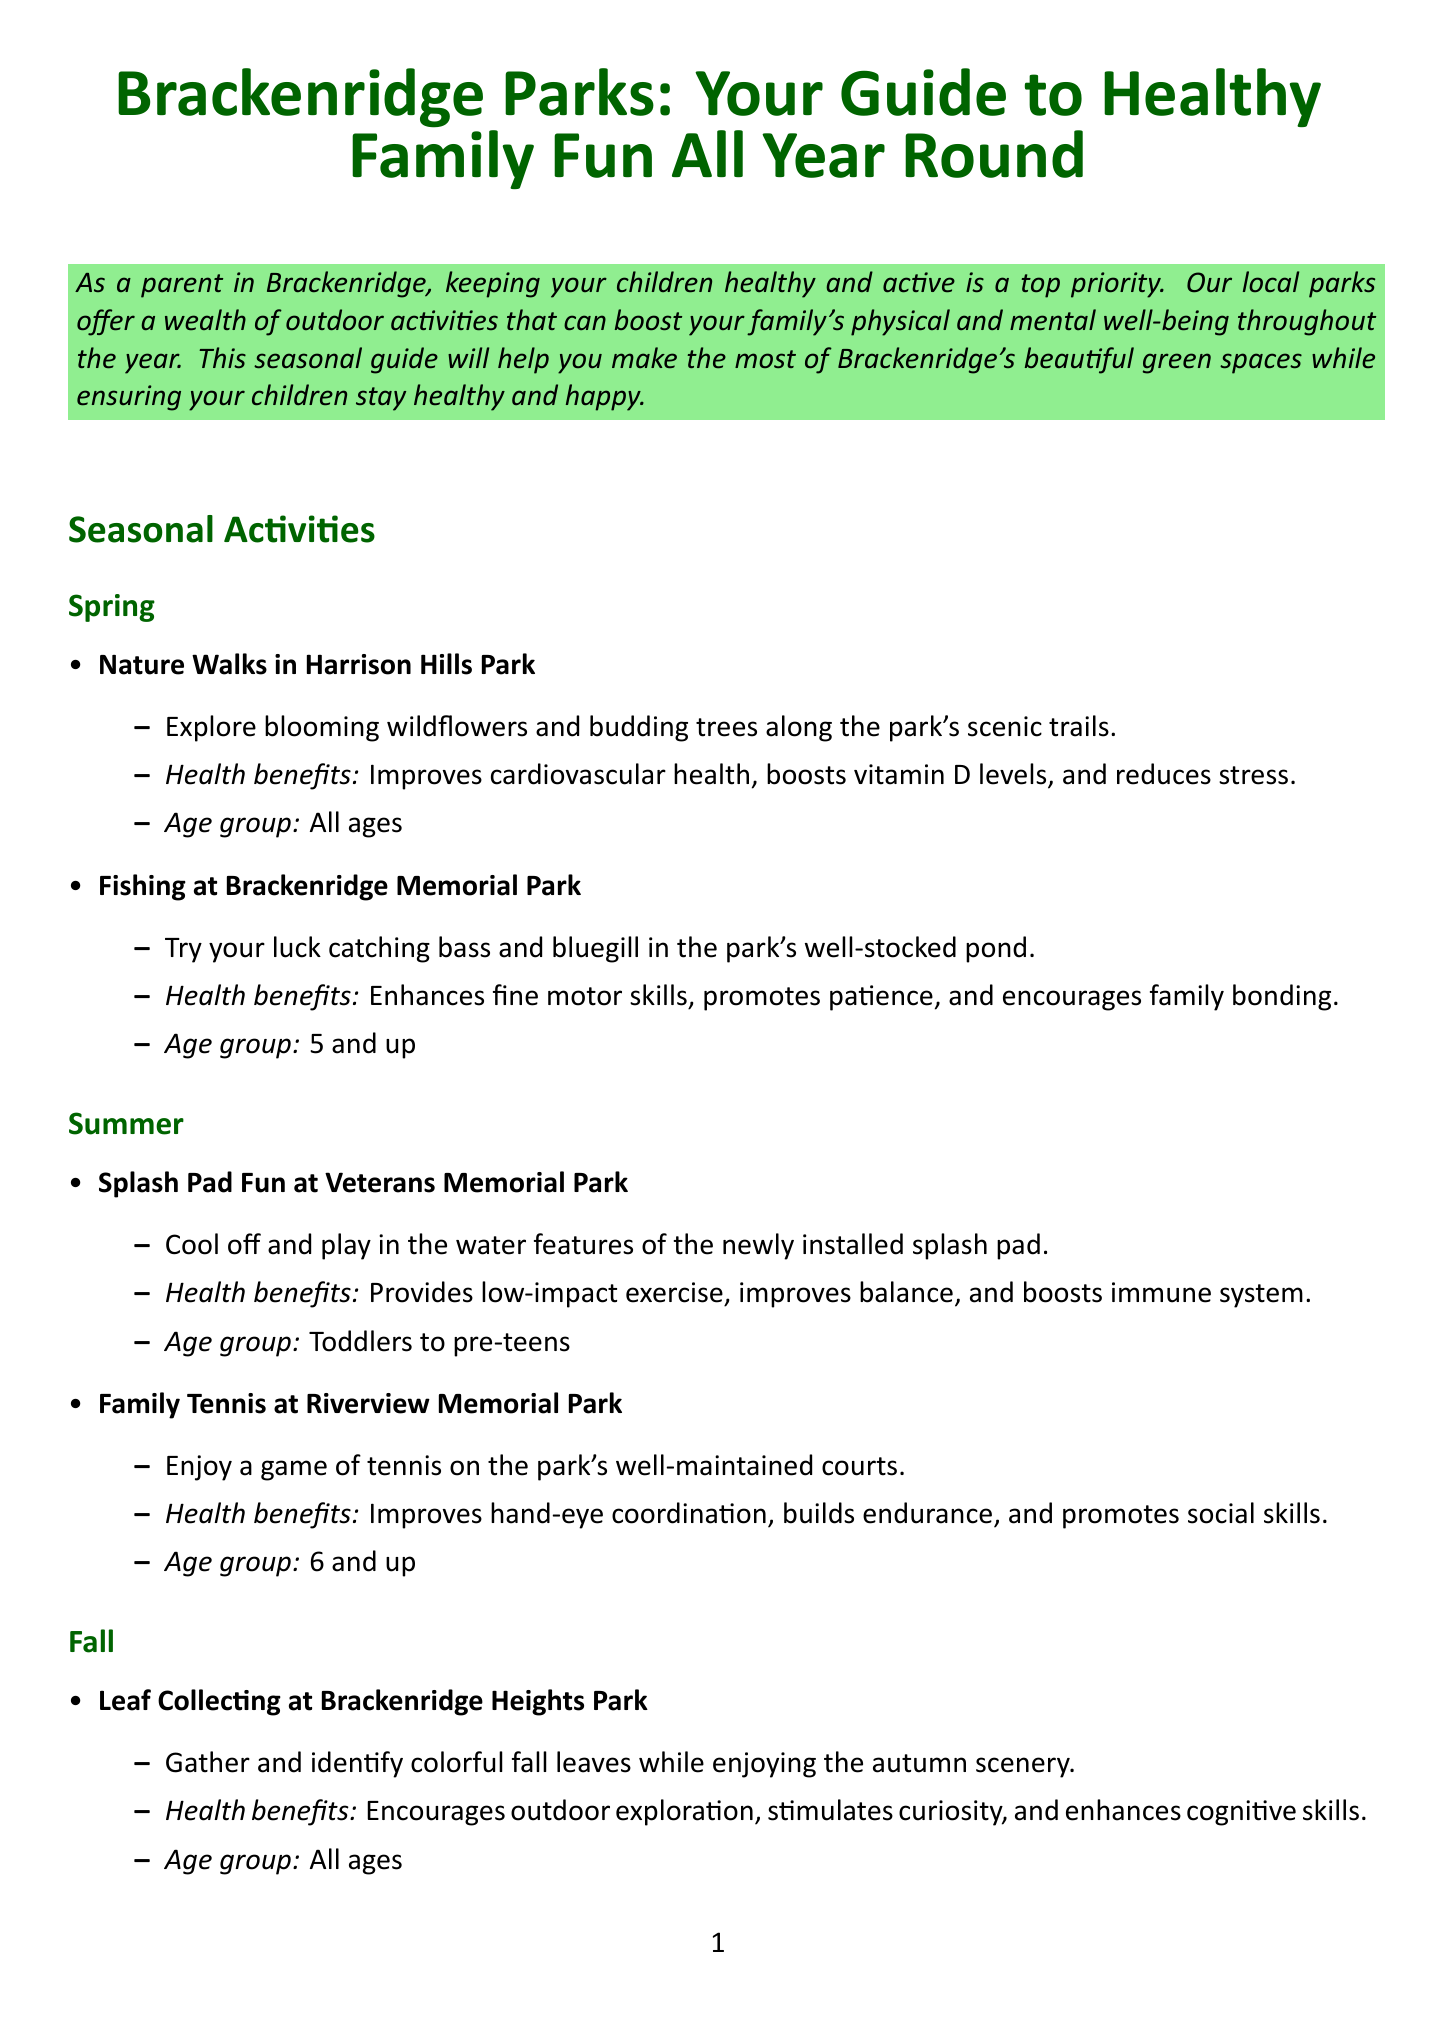What is the title of the newsletter? The title is presented prominently at the beginning of the document and serves as the main heading.
Answer: Brackenridge Parks: Your Guide to Healthy Family Fun All Year Round What is one health benefit of fishing at Brackenridge Memorial Park? Fishing is highlighted within the seasonal activities, emphasizing its health benefits for children.
Answer: Enhances fine motor skills What age group is suggested for Family Tennis at Riverview Memorial Park? The recommended age group is explicitly mentioned under the activity section of summer.
Answer: 6 and up Which park offers a splash pad for cooling off? The document specifies the location of the splash pad under summer activities.
Answer: Veterans Memorial Park What are two health tips mentioned in the newsletter? The health tips provide practical advice for outdoor activities, detailed in a list format.
Answer: Always apply sunscreen, Stay hydrated What seasonal activity encourages outdoor exploration during fall? The activity for fall includes specific tasks that enhance children’s curiosity and exploration.
Answer: Leaf Collecting at Brackenridge Heights Park What is the contact number for the Brackenridge Recreation Department? The document lists contact information for local resources, including this department.
Answer: 724-224-7999 Which activity in winter promotes mindfulness? The full health benefits and details are outlined in the winter section related to this activity.
Answer: Winter Bird Watching at Tarentum Riverfront Park 